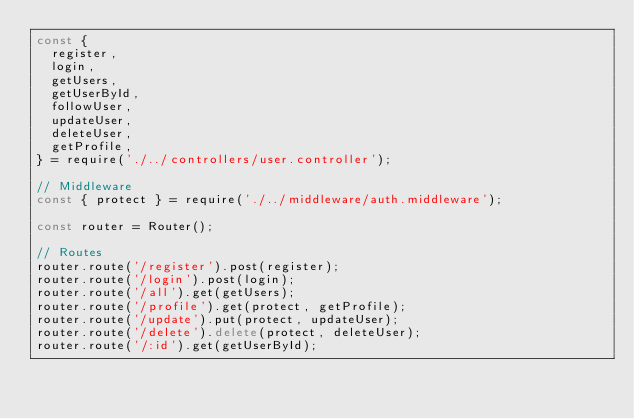Convert code to text. <code><loc_0><loc_0><loc_500><loc_500><_JavaScript_>const {
  register,
  login,
  getUsers,
  getUserById,
  followUser,
  updateUser,
  deleteUser,
  getProfile,
} = require('./../controllers/user.controller');

// Middleware
const { protect } = require('./../middleware/auth.middleware');

const router = Router();

// Routes
router.route('/register').post(register);
router.route('/login').post(login);
router.route('/all').get(getUsers);
router.route('/profile').get(protect, getProfile);
router.route('/update').put(protect, updateUser);
router.route('/delete').delete(protect, deleteUser);
router.route('/:id').get(getUserById);</code> 